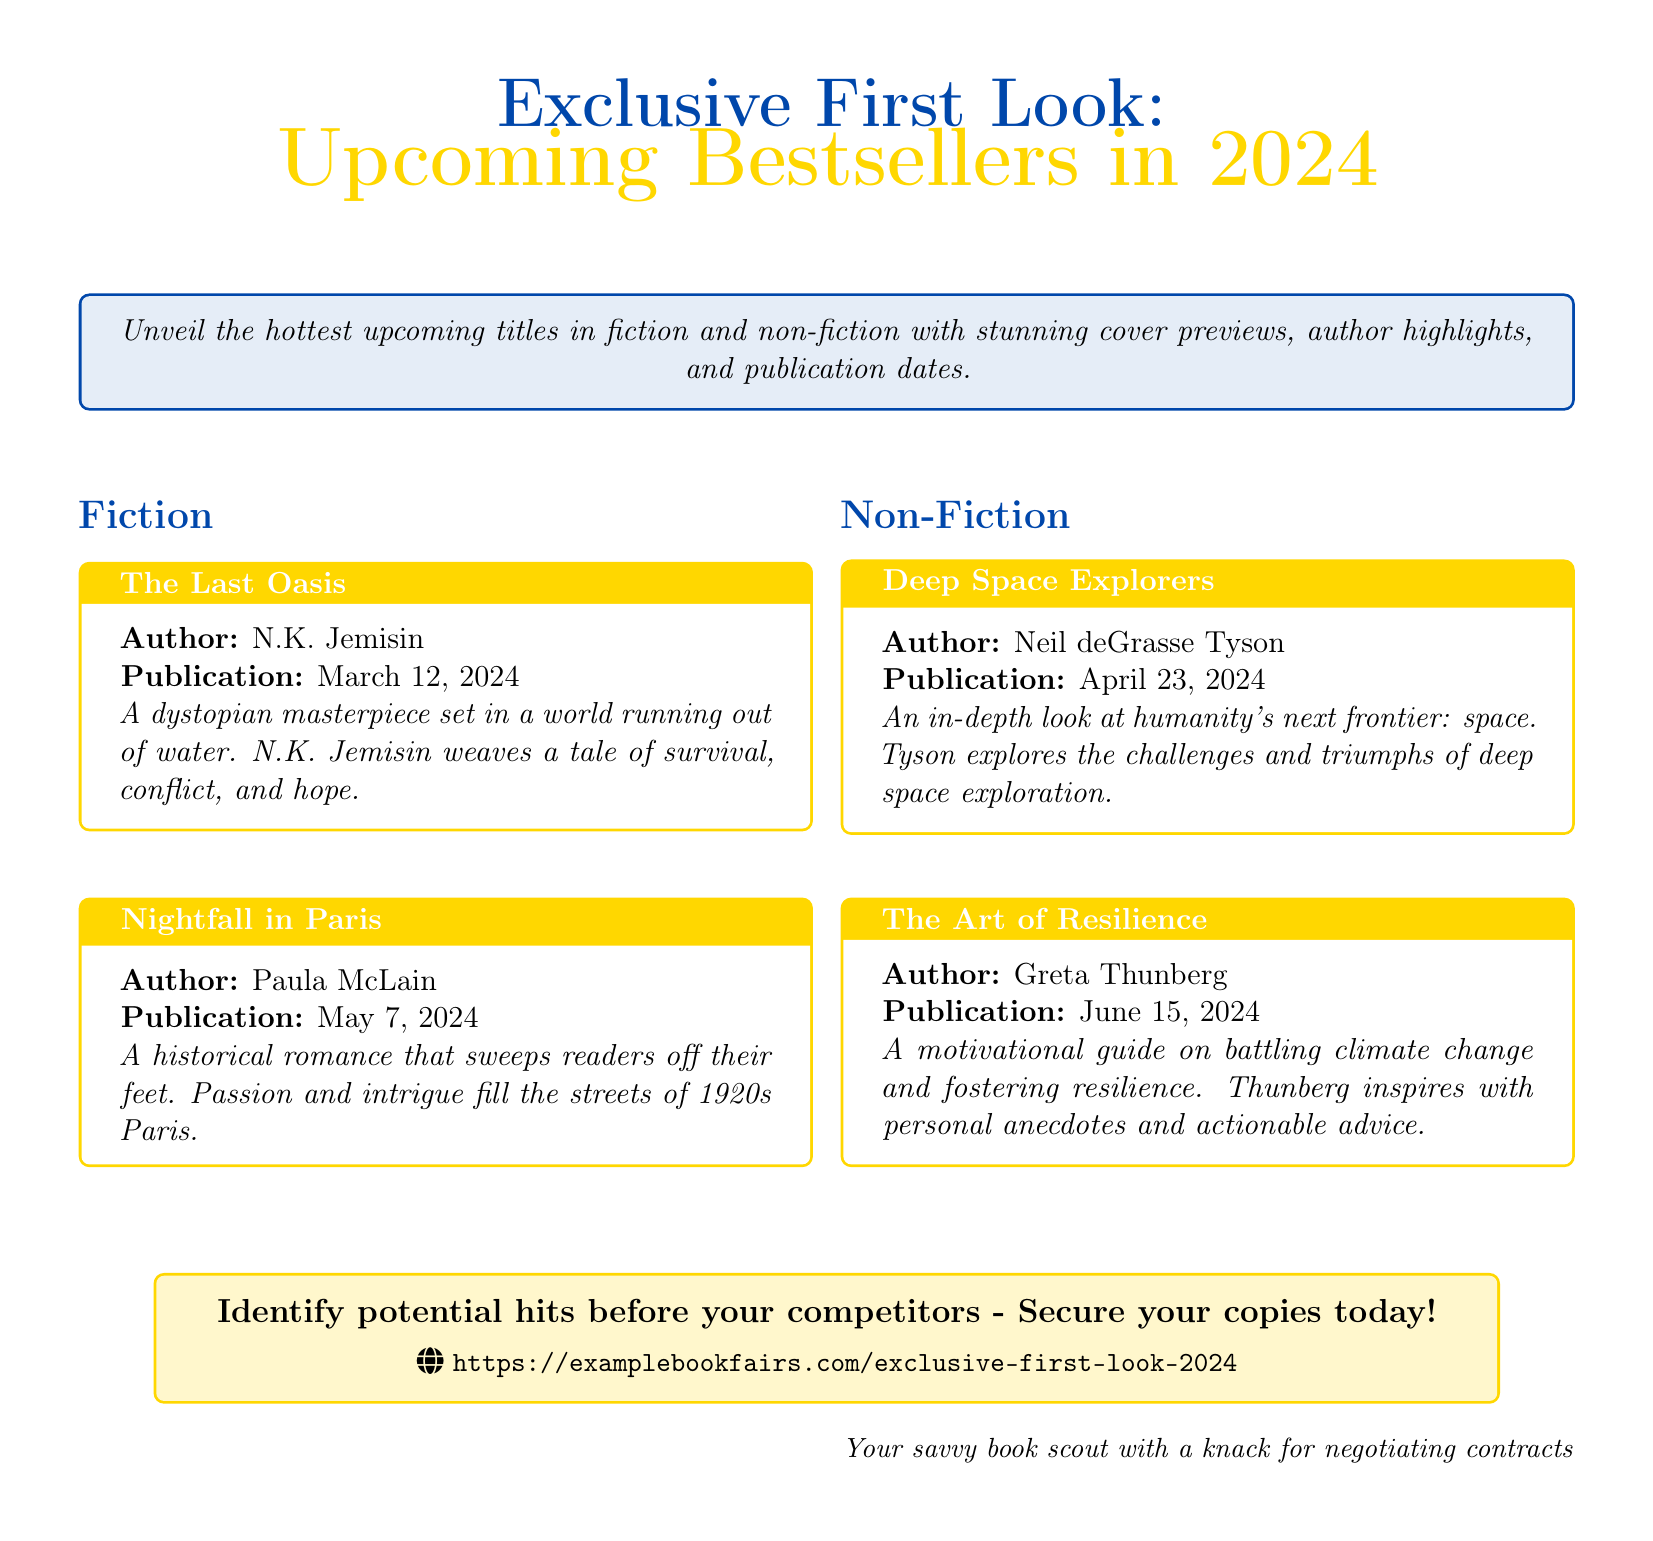What is the publication date of "The Last Oasis"? The publication date is specified in the document under the title for "The Last Oasis."
Answer: March 12, 2024 Who is the author of "Deep Space Explorers"? The author of "Deep Space Explorers" is mentioned in the respective title box in the document.
Answer: Neil deGrasse Tyson What genre does "Nightfall in Paris" belong to? The genre of "Nightfall in Paris" is indicated in the fiction section of the document.
Answer: Historical romance How many upcoming titles are highlighted in the document? The document presents a total of four upcoming titles across fiction and non-fiction sections.
Answer: Four What is the overarching theme of the document? The theme is derived from the introductory statement about unveiling upcoming bestsellers.
Answer: Upcoming bestsellers When is "The Art of Resilience" set to be published? The publication date for "The Art of Resilience" is found in its title box in the non-fiction section.
Answer: June 15, 2024 What is the call to action in the document? The call to action is found in the concluding statement encouraging the reader to secure copies.
Answer: Secure your copies today How many fiction titles are listed in the document? The document lists two titles under the fiction category.
Answer: Two What is the color of the header in the document? The color of the header can be identified from the formatting details provided in the document.
Answer: My blue 